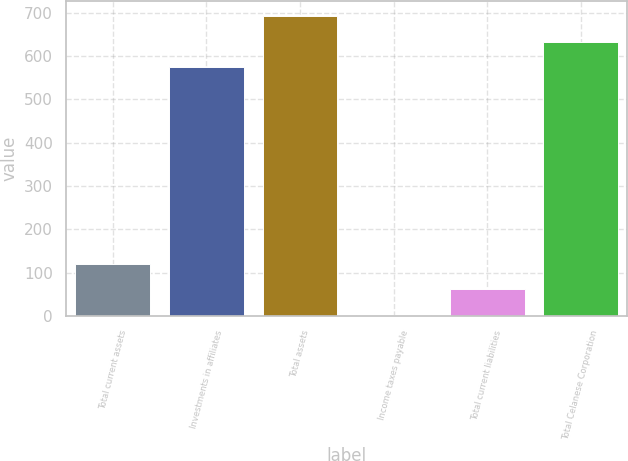Convert chart. <chart><loc_0><loc_0><loc_500><loc_500><bar_chart><fcel>Total current assets<fcel>Investments in affiliates<fcel>Total assets<fcel>Income taxes payable<fcel>Total current liabilities<fcel>Total Celanese Corporation<nl><fcel>120.6<fcel>574<fcel>691.6<fcel>3<fcel>61.8<fcel>632.8<nl></chart> 